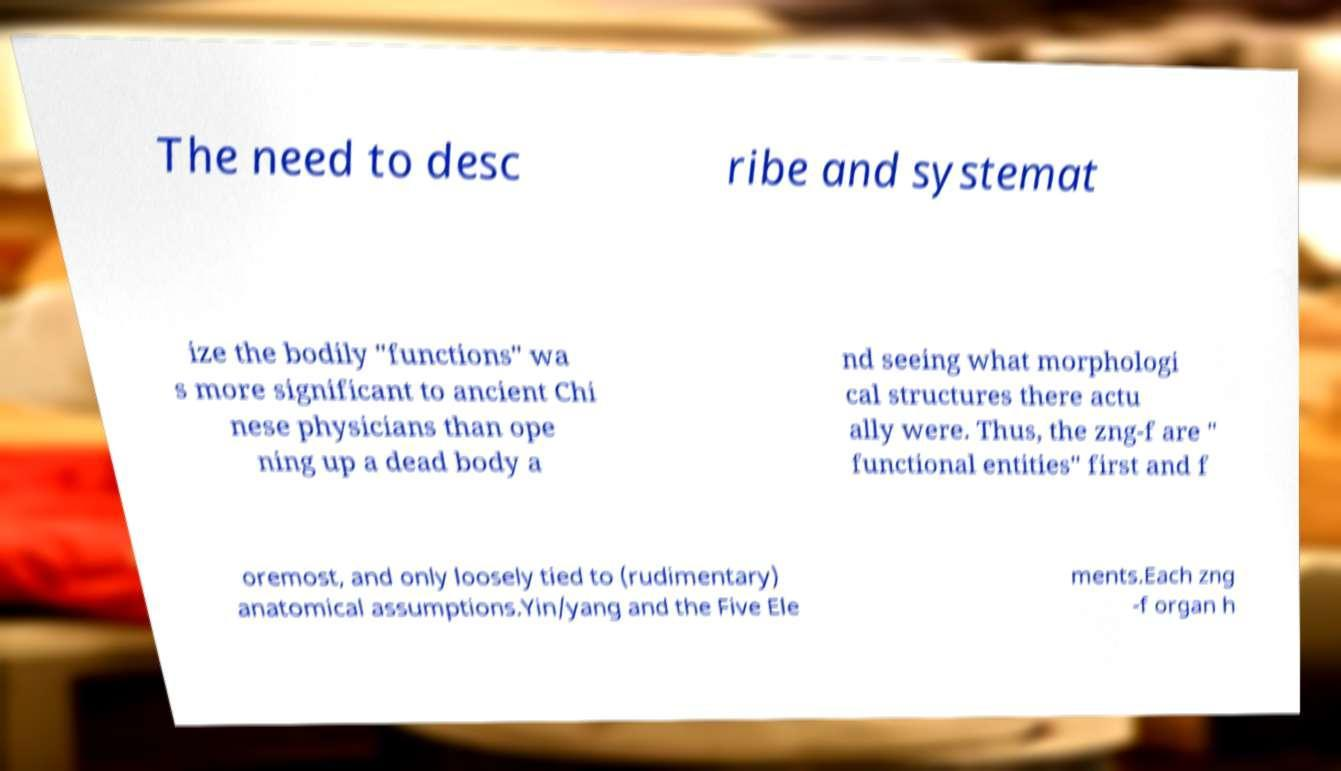Can you accurately transcribe the text from the provided image for me? The need to desc ribe and systemat ize the bodily "functions" wa s more significant to ancient Chi nese physicians than ope ning up a dead body a nd seeing what morphologi cal structures there actu ally were. Thus, the zng-f are " functional entities" first and f oremost, and only loosely tied to (rudimentary) anatomical assumptions.Yin/yang and the Five Ele ments.Each zng -f organ h 